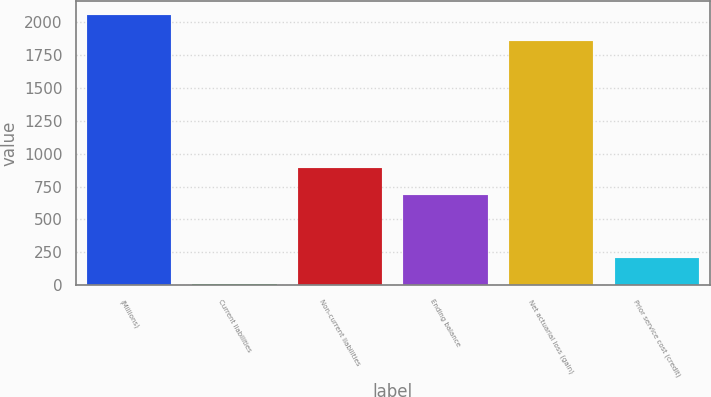Convert chart. <chart><loc_0><loc_0><loc_500><loc_500><bar_chart><fcel>(Millions)<fcel>Current liabilities<fcel>Non-current liabilities<fcel>Ending balance<fcel>Net actuarial loss (gain)<fcel>Prior service cost (credit)<nl><fcel>2058.3<fcel>8<fcel>889.3<fcel>689<fcel>1858<fcel>208.3<nl></chart> 